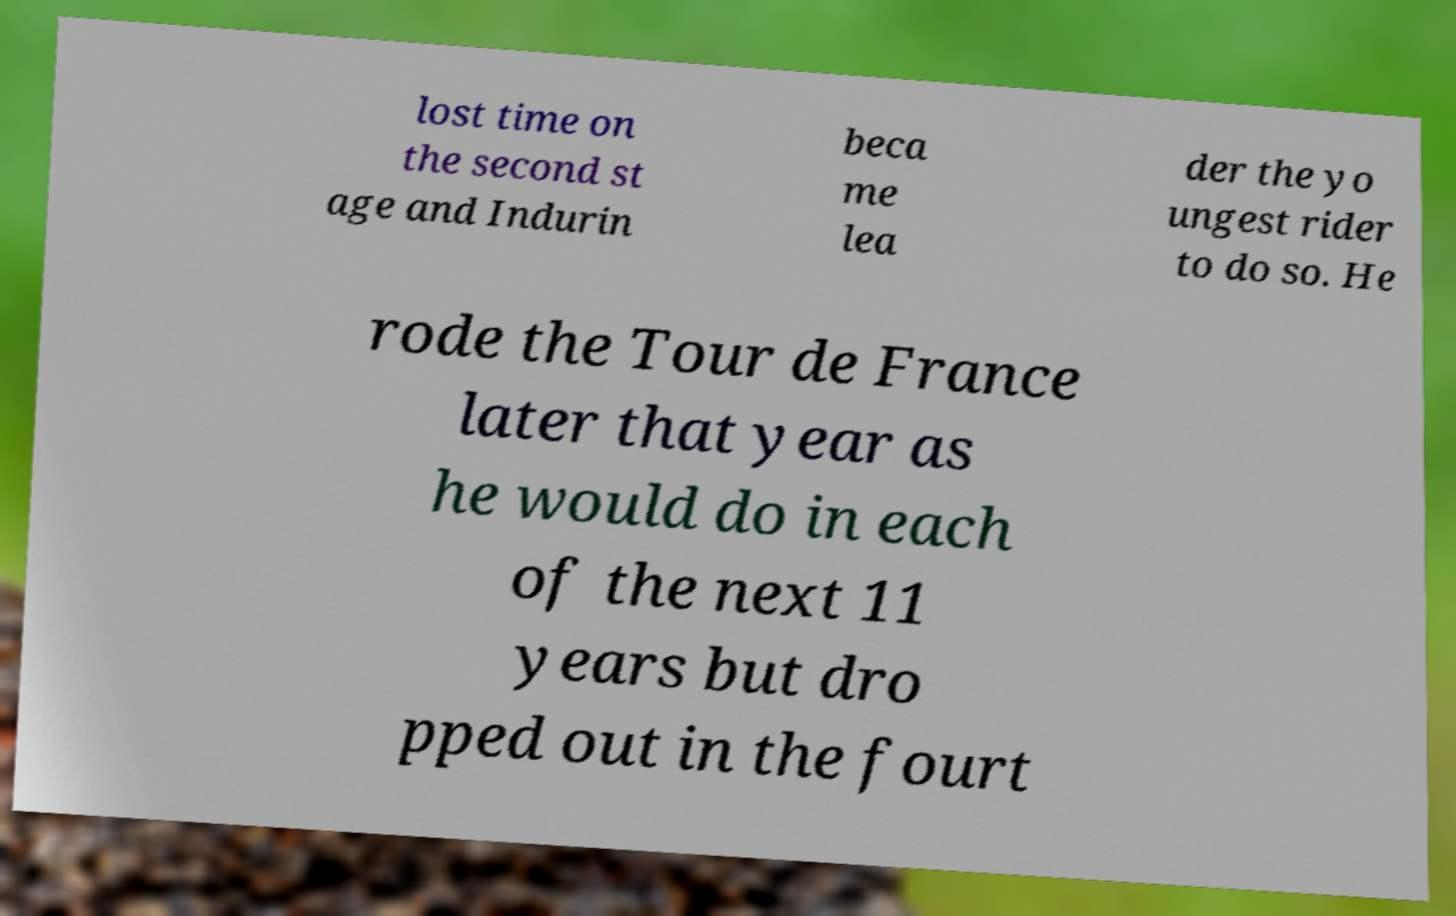Can you read and provide the text displayed in the image?This photo seems to have some interesting text. Can you extract and type it out for me? lost time on the second st age and Indurin beca me lea der the yo ungest rider to do so. He rode the Tour de France later that year as he would do in each of the next 11 years but dro pped out in the fourt 